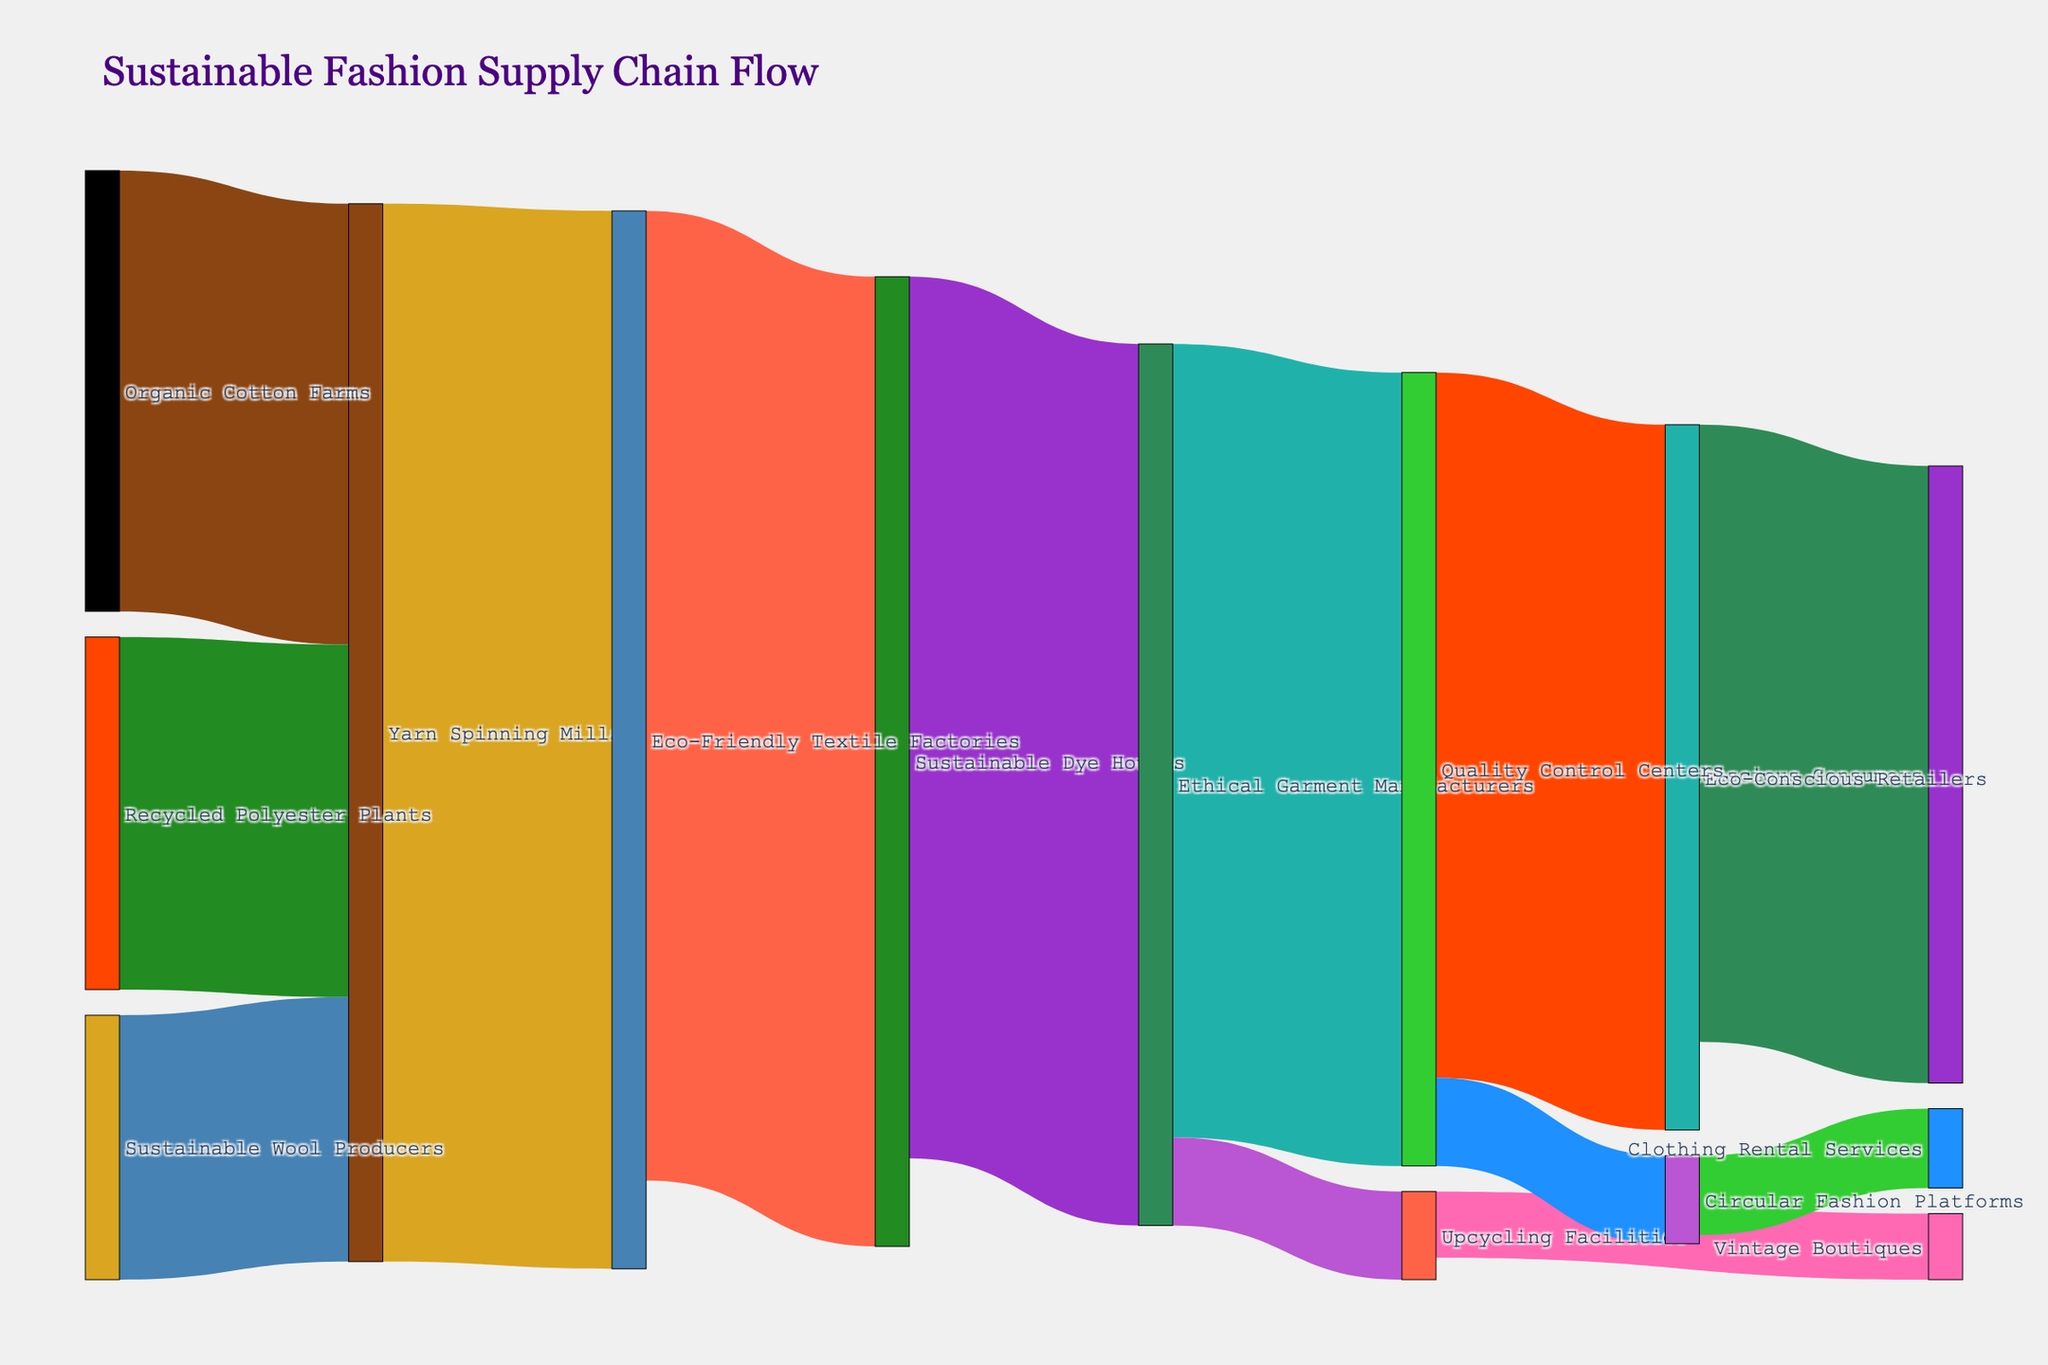What's the primary material source for yarn spinning mills? By examining the flow of materials in the Sankey diagram, we can see that yarn spinning mills receive input from Organic Cotton Farms (1,000 units), Recycled Polyester Plants (800 units), and Sustainable Wool Producers (600 units). Adding these values shows that Organic Cotton Farms provide the largest input.
Answer: Organic Cotton Farms How much material flows from ethical garment manufacturers to quality control centers? The Sankey diagram shows a directed link from ethical garment manufacturers to quality control centers, with a flow value labeled as 1,800 units.
Answer: 1,800 units Which material source contributes the least to yarn spinning mills? The diagram shows that yarn spinning mills receive inputs from Organic Cotton Farms (1,000 units), Recycled Polyester Plants (800 units), and Sustainable Wool Producers (600 units). The smallest value is from Sustainable Wool Producers.
Answer: Sustainable Wool Producers What is the total material flow to eco-conscious retailers? The total material flow to eco-conscious retailers includes 1,600 units from quality control centers.
Answer: 1,600 units How many different stages are shown in the supply chain flow, from the source to the final product? The stages can be counted by tracing from the source materials (Organic Cotton Farms, Recycled Polyester Plants, Sustainable Wool Producers) through intermediary stages (yarn spinning mills, etc.) to the end consumers (conscious consumers, vintage boutiques, clothing rental services). We count a total of 10 stages: Organic Cotton Farms, Recycled Polyester Plants, Sustainable Wool Producers, Yarn Spinning Mills, Eco-Friendly Textile Factories, Sustainable Dye Houses, Ethical Garment Manufacturers, Quality Control Centers, Eco-Conscious Retailers, Conscious Consumers, Upcycling Facilities, Vintage Boutiques, Circular Fashion Platforms, Clothing Rental Services.
Answer: 10 stages What stage in the supply chain has the most diverse outgoing paths? To determine which stage has the most diverse outgoing paths, we look at the points in the diagram where multiple arrows originate. Ethical Garment Manufacturers have connections to Quality Control Centers (1,800 units) and Upcycling Facilities (200 units), making it the stage with the most diverse outgoing paths.
Answer: Ethical Garment Manufacturers Which stage directly impacts conscious consumers, and what is the amount? The Sankey diagram shows eco-conscious retailers directly connected to conscious consumers with an amount labeled as 1,400 units.
Answer: Eco-conscious retailers, 1,400 units How much material is directed towards circular fashion platforms? Circular fashion platforms receive input from quality control centers with a value of 200 units as shown in the Sankey diagram.
Answer: 200 units 